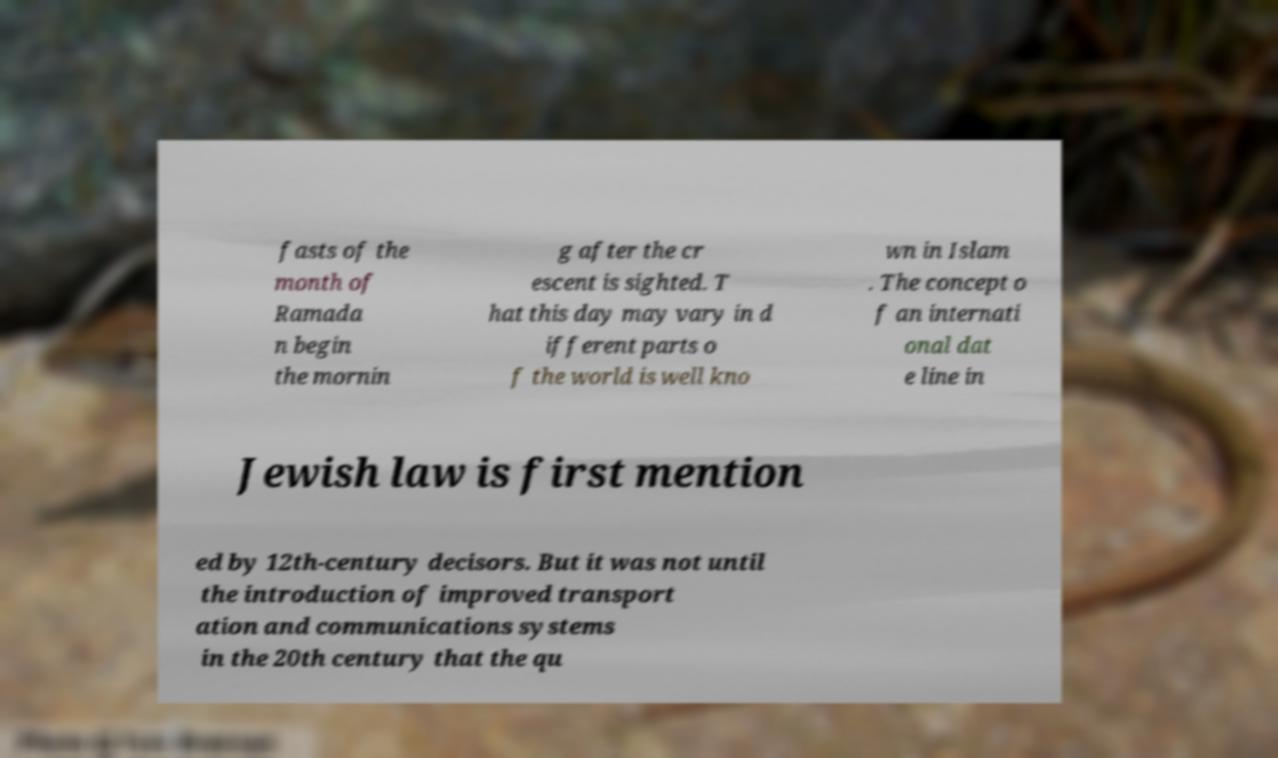There's text embedded in this image that I need extracted. Can you transcribe it verbatim? fasts of the month of Ramada n begin the mornin g after the cr escent is sighted. T hat this day may vary in d ifferent parts o f the world is well kno wn in Islam . The concept o f an internati onal dat e line in Jewish law is first mention ed by 12th-century decisors. But it was not until the introduction of improved transport ation and communications systems in the 20th century that the qu 